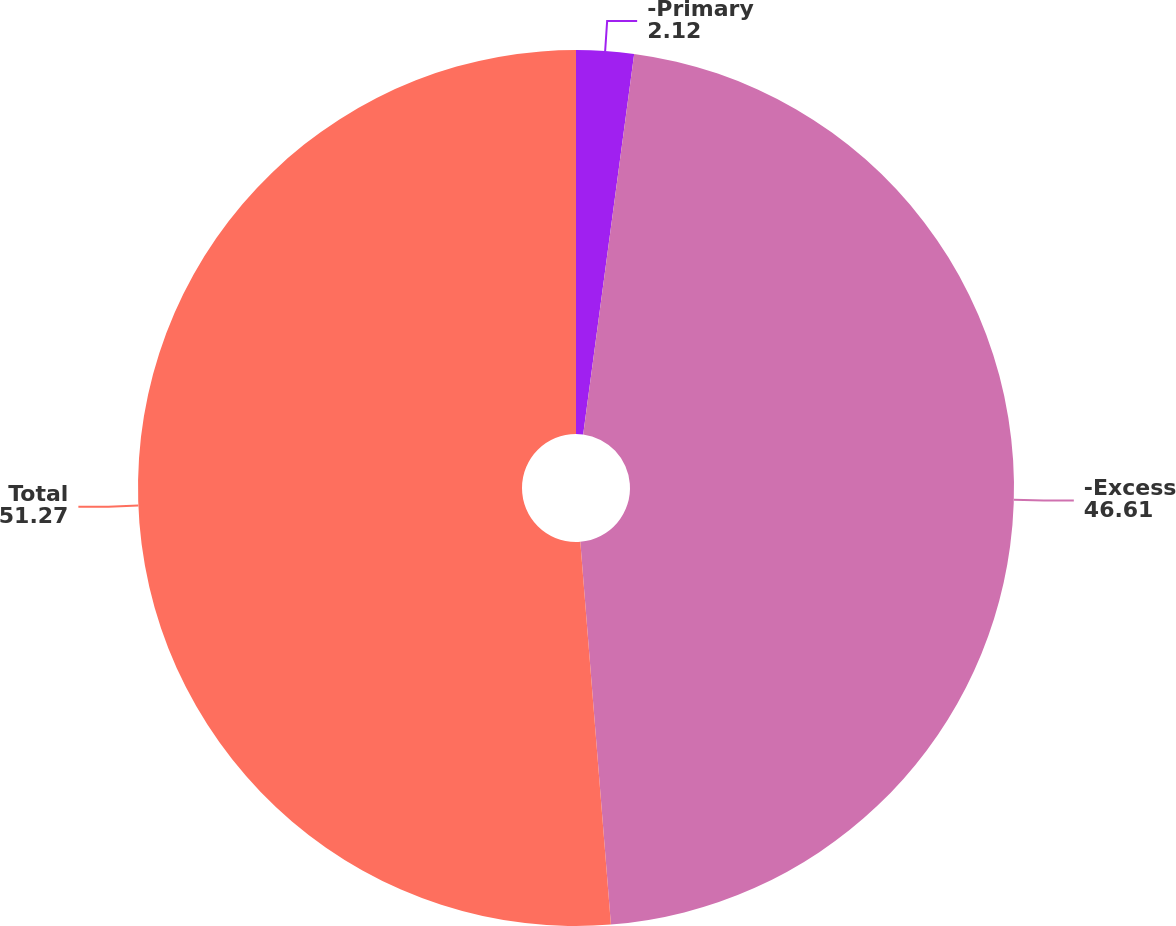Convert chart. <chart><loc_0><loc_0><loc_500><loc_500><pie_chart><fcel>-Primary<fcel>-Excess<fcel>Total<nl><fcel>2.12%<fcel>46.61%<fcel>51.27%<nl></chart> 